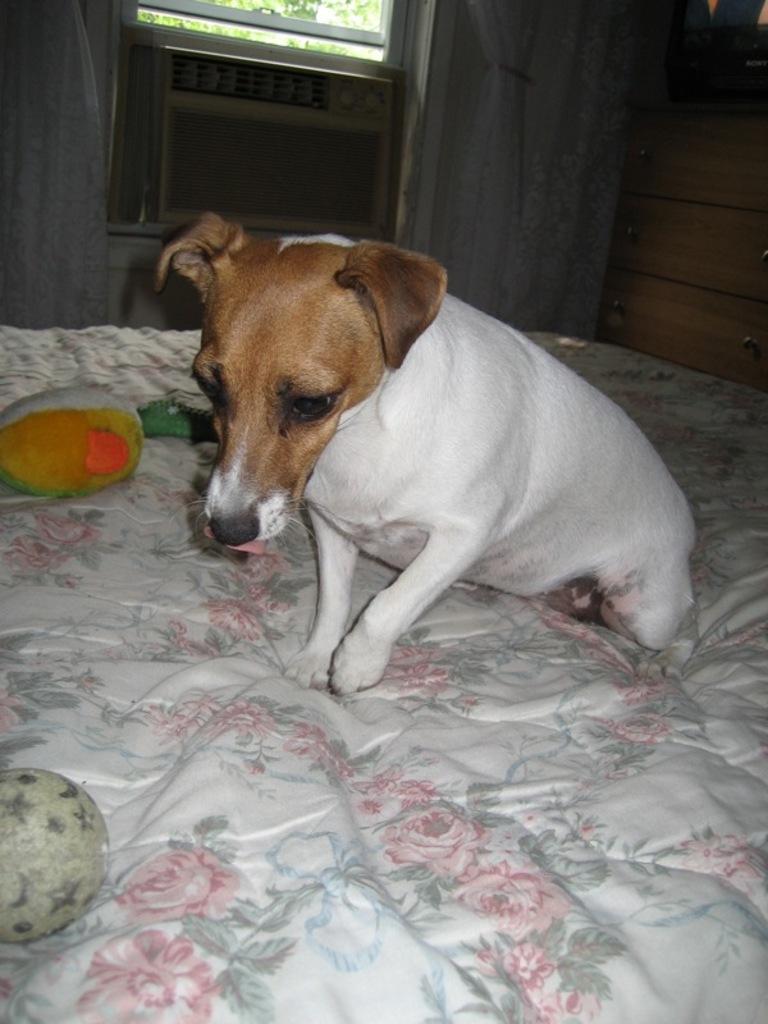How would you summarize this image in a sentence or two? In this image in front there is a dog on the bed. In front of the dog there are few objects. Behind the dog there is a cooler. There are curtains. There is a glass window through which we can see trees. On the right side of the image there are wooden racks. On top of it there is some object. 